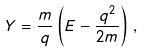<formula> <loc_0><loc_0><loc_500><loc_500>Y = \frac { m } { q } \left ( E - \frac { q ^ { 2 } } { 2 m } \right ) \, ,</formula> 